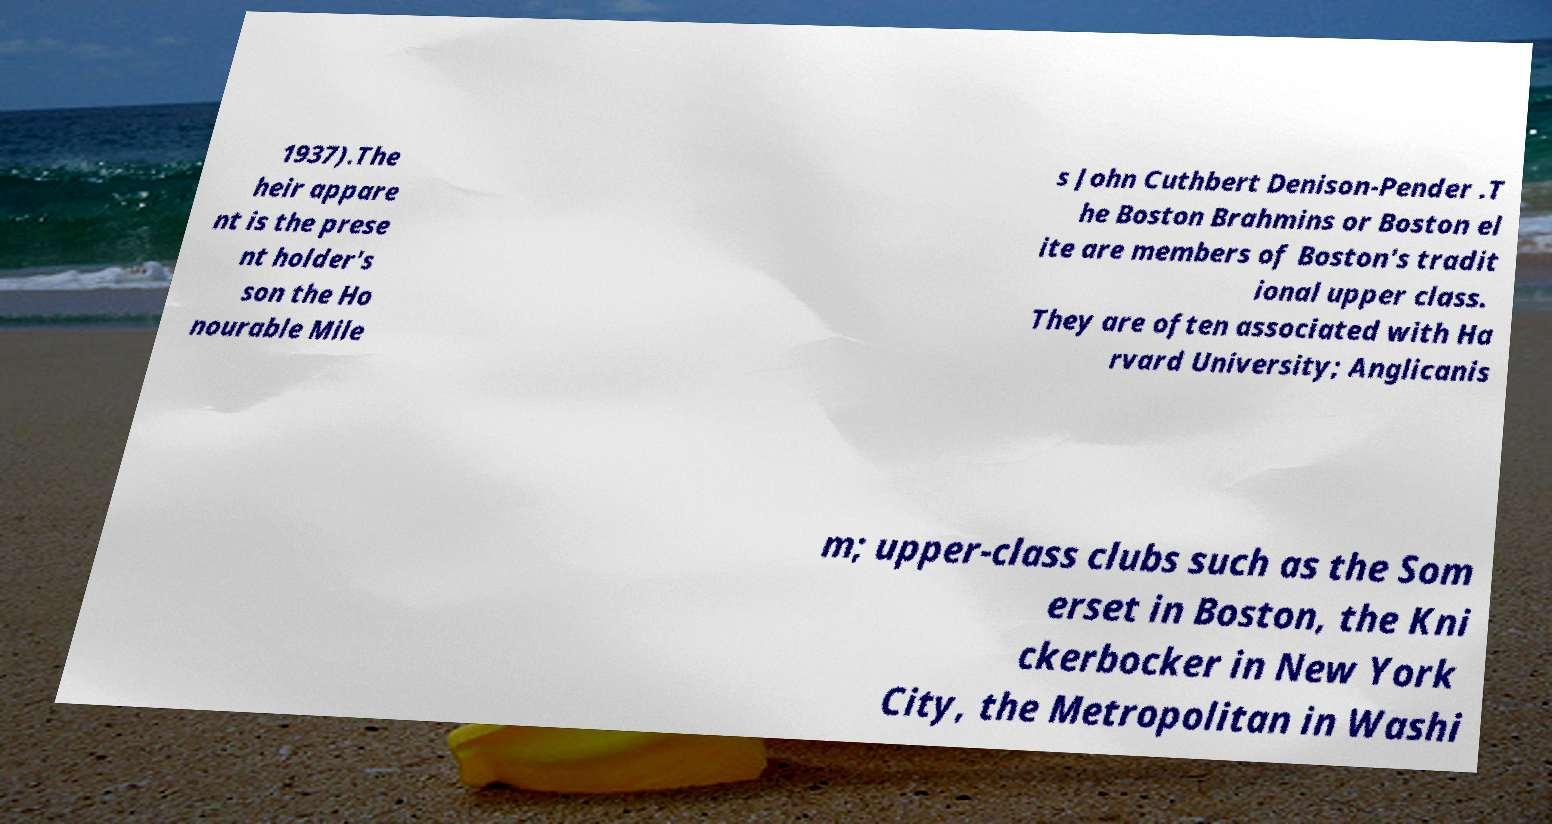Please identify and transcribe the text found in this image. 1937).The heir appare nt is the prese nt holder's son the Ho nourable Mile s John Cuthbert Denison-Pender .T he Boston Brahmins or Boston el ite are members of Boston's tradit ional upper class. They are often associated with Ha rvard University; Anglicanis m; upper-class clubs such as the Som erset in Boston, the Kni ckerbocker in New York City, the Metropolitan in Washi 